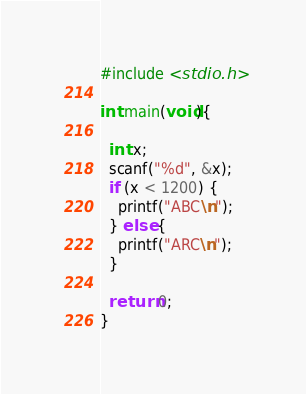Convert code to text. <code><loc_0><loc_0><loc_500><loc_500><_C_>#include <stdio.h>

int main(void){

  int x;
  scanf("%d", &x);
  if (x < 1200) {
    printf("ABC\n");
  } else {
    printf("ARC\n");
  }

  return 0;
}</code> 